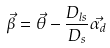Convert formula to latex. <formula><loc_0><loc_0><loc_500><loc_500>\vec { \beta } = \vec { \theta } - \frac { D _ { l s } } { D _ { s } } \vec { \alpha _ { d } }</formula> 